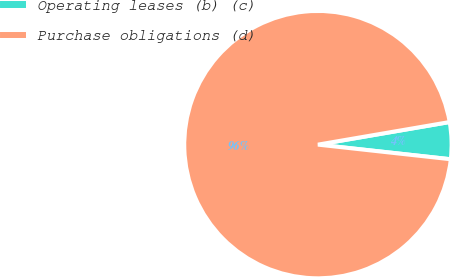<chart> <loc_0><loc_0><loc_500><loc_500><pie_chart><fcel>Operating leases (b) (c)<fcel>Purchase obligations (d)<nl><fcel>4.45%<fcel>95.55%<nl></chart> 